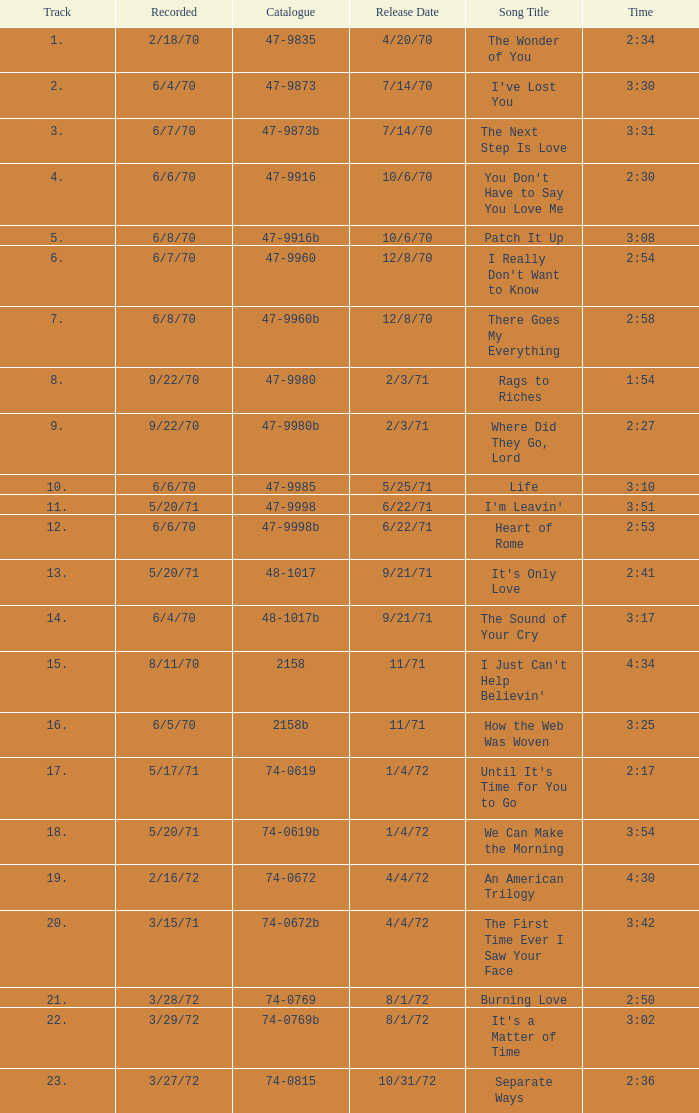What is the catalogue number for the song that is 3:17 and was released 9/21/71? 48-1017b. 